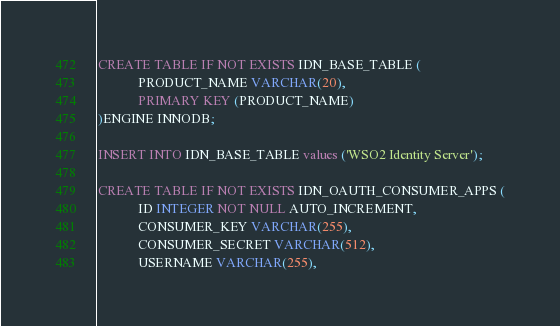Convert code to text. <code><loc_0><loc_0><loc_500><loc_500><_SQL_>CREATE TABLE IF NOT EXISTS IDN_BASE_TABLE (
            PRODUCT_NAME VARCHAR(20),
            PRIMARY KEY (PRODUCT_NAME)
)ENGINE INNODB;

INSERT INTO IDN_BASE_TABLE values ('WSO2 Identity Server');

CREATE TABLE IF NOT EXISTS IDN_OAUTH_CONSUMER_APPS (
            ID INTEGER NOT NULL AUTO_INCREMENT,
            CONSUMER_KEY VARCHAR(255),
            CONSUMER_SECRET VARCHAR(512),
            USERNAME VARCHAR(255),</code> 